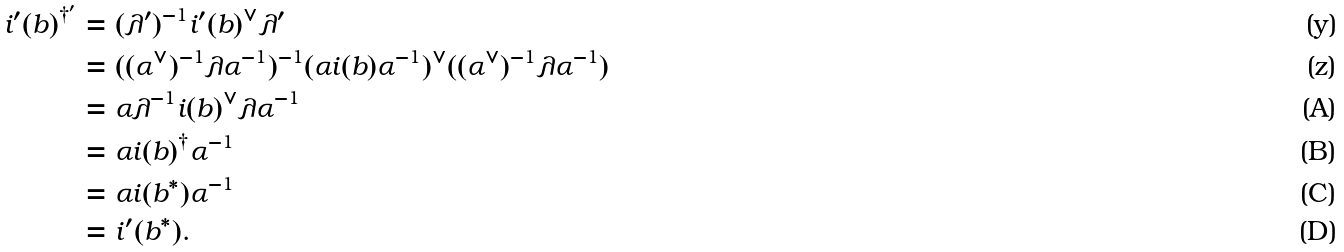<formula> <loc_0><loc_0><loc_500><loc_500>i ^ { \prime } ( b ) ^ { \dag ^ { \prime } } & = ( \lambda ^ { \prime } ) ^ { - 1 } i ^ { \prime } ( b ) ^ { \vee } \lambda ^ { \prime } \\ & = ( ( \alpha ^ { \vee } ) ^ { - 1 } \lambda \alpha ^ { - 1 } ) ^ { - 1 } ( \alpha i ( b ) \alpha ^ { - 1 } ) ^ { \vee } ( ( \alpha ^ { \vee } ) ^ { - 1 } \lambda \alpha ^ { - 1 } ) \\ & = \alpha \lambda ^ { - 1 } i ( b ) ^ { \vee } \lambda \alpha ^ { - 1 } \\ & = \alpha i ( b ) ^ { \dag } \alpha ^ { - 1 } \\ & = \alpha i ( b ^ { * } ) \alpha ^ { - 1 } \\ & = i ^ { \prime } ( b ^ { * } ) .</formula> 